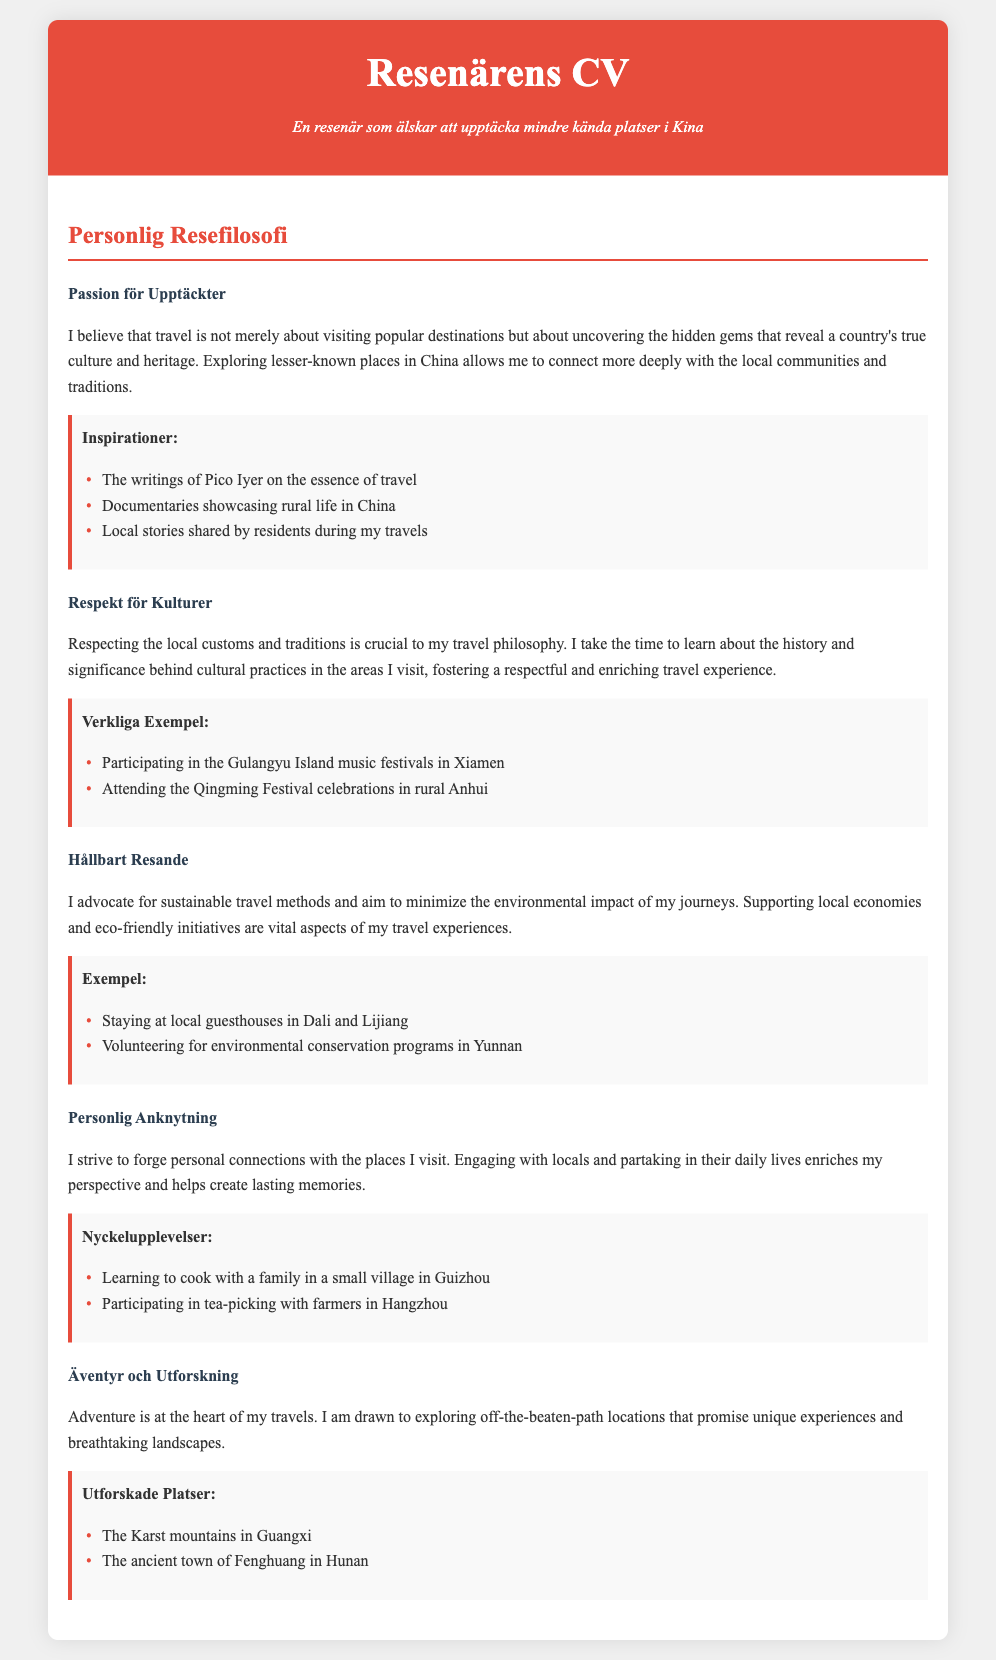what is the title of the document? The title stated in the document reflects the identity and focus of the traveler, which is "Resenärens CV - Upptäcka Kina."
Answer: Resenärens CV - Upptäcka Kina what does the subtitle describe? The subtitle provides insight into the traveler's passion, emphasizing their interest in discovering lesser-known locations in China.
Answer: En resenär som älskar att upptäcka mindre kända platser i Kina who is the author inspired by regarding travel? The author cites specific writers as influencers, particularly Pico Iyer, who discusses the essence of travel.
Answer: Pico Iyer what are the examples under "Respekt för Kulturer"? The section on cultural respect includes real-life activities that illuminate the author's engagement with local traditions, such as music festivals and festival celebrations.
Answer: Participating in the Gulangyu Island music festivals in Xiamen; Attending the Qingming Festival celebrations in rural Anhui which two locations are highlighted as explored places? This question addresses the author's spirit of adventure and desire to explore unique and off-the-beaten-path destinations, such as mountainous areas and historical towns.
Answer: The Karst mountains in Guangxi; The ancient town of Fenghuang in Hunan how does the author connect with local people during travels? The author emphasizes personal engagement with local communities to create lasting connections and memories through specific activities.
Answer: Learning to cook with a family in a small village in Guizhou; Participating in tea-picking with farmers in Hangzhou 